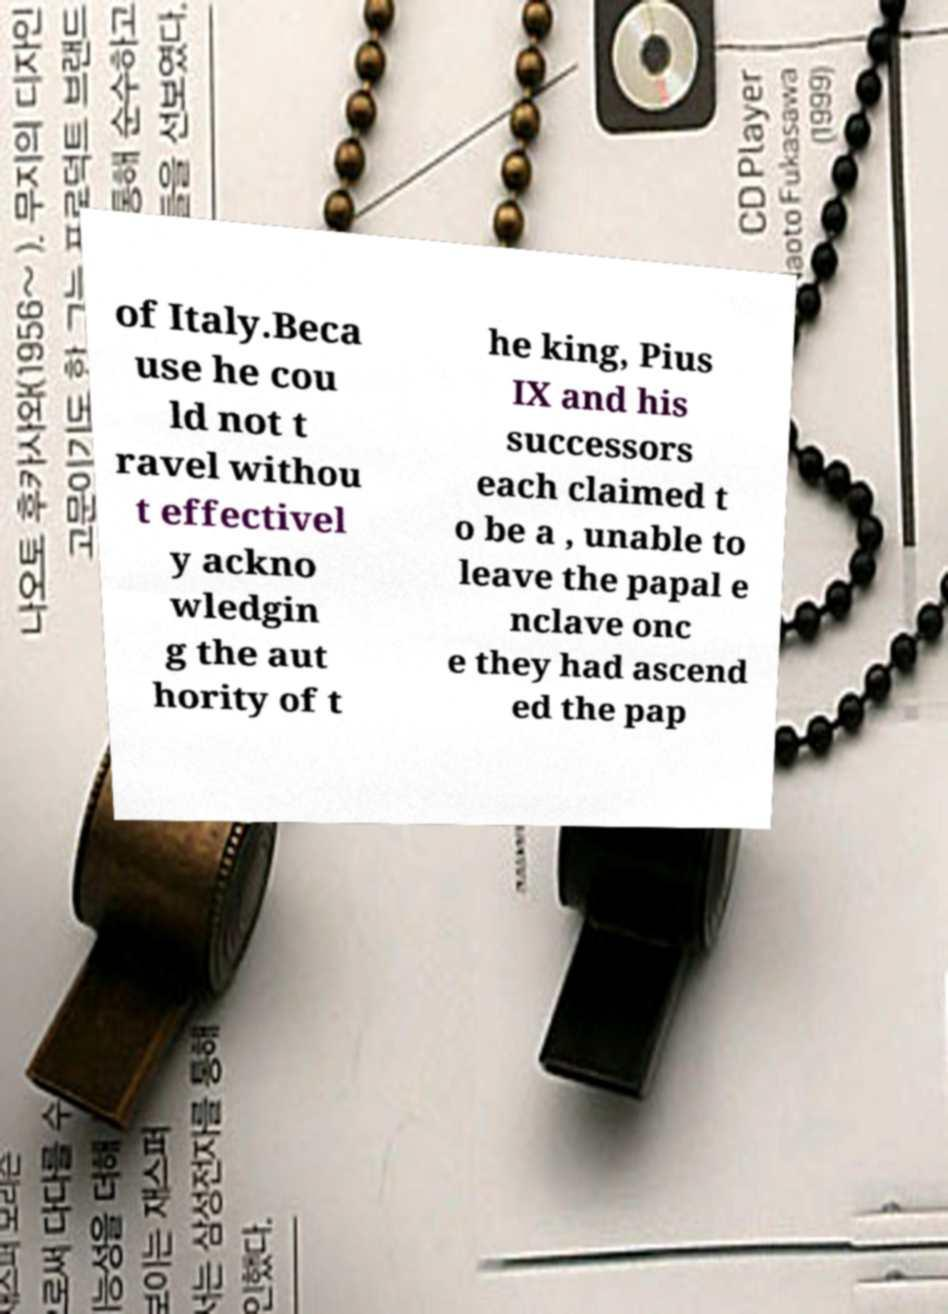Could you extract and type out the text from this image? of Italy.Beca use he cou ld not t ravel withou t effectivel y ackno wledgin g the aut hority of t he king, Pius IX and his successors each claimed t o be a , unable to leave the papal e nclave onc e they had ascend ed the pap 